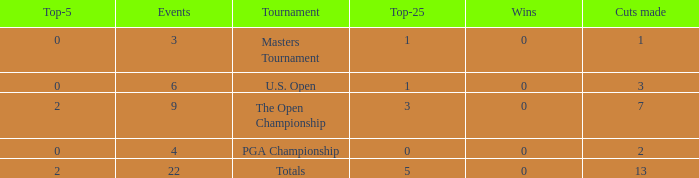What is the fewest number of top-25s for events with more than 13 cuts made? None. 